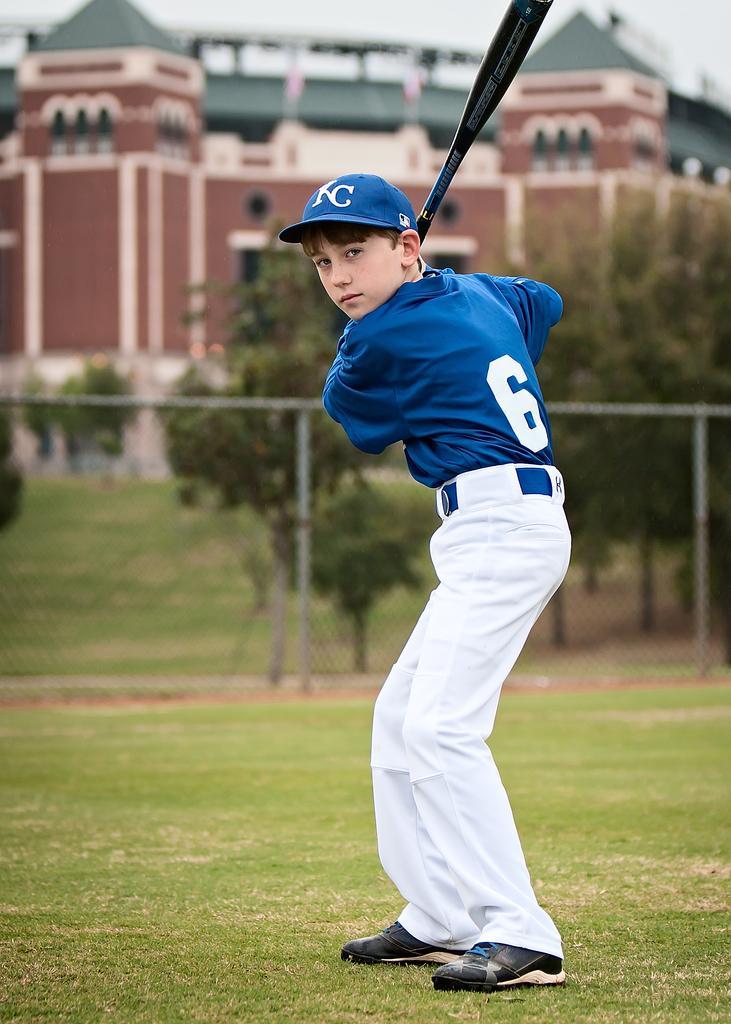Describe this image in one or two sentences. In this image we can see a boy wearing dress and cap is holding a baseball bat in his hand. In the background, we can see a fence, a group of trees, building and the sky. 